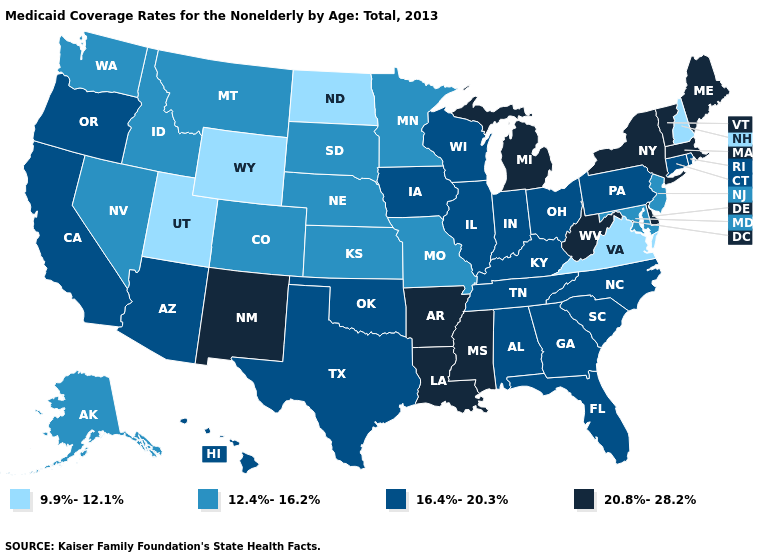Does Utah have the lowest value in the USA?
Short answer required. Yes. Does Wisconsin have a higher value than Wyoming?
Be succinct. Yes. How many symbols are there in the legend?
Write a very short answer. 4. Does Utah have the lowest value in the USA?
Give a very brief answer. Yes. Does Iowa have the highest value in the MidWest?
Answer briefly. No. What is the lowest value in the Northeast?
Keep it brief. 9.9%-12.1%. What is the highest value in states that border Alabama?
Write a very short answer. 20.8%-28.2%. What is the highest value in the USA?
Short answer required. 20.8%-28.2%. Among the states that border Arizona , does Colorado have the lowest value?
Give a very brief answer. No. Does West Virginia have the highest value in the USA?
Concise answer only. Yes. Which states have the lowest value in the USA?
Give a very brief answer. New Hampshire, North Dakota, Utah, Virginia, Wyoming. What is the value of Delaware?
Give a very brief answer. 20.8%-28.2%. What is the highest value in the Northeast ?
Concise answer only. 20.8%-28.2%. 